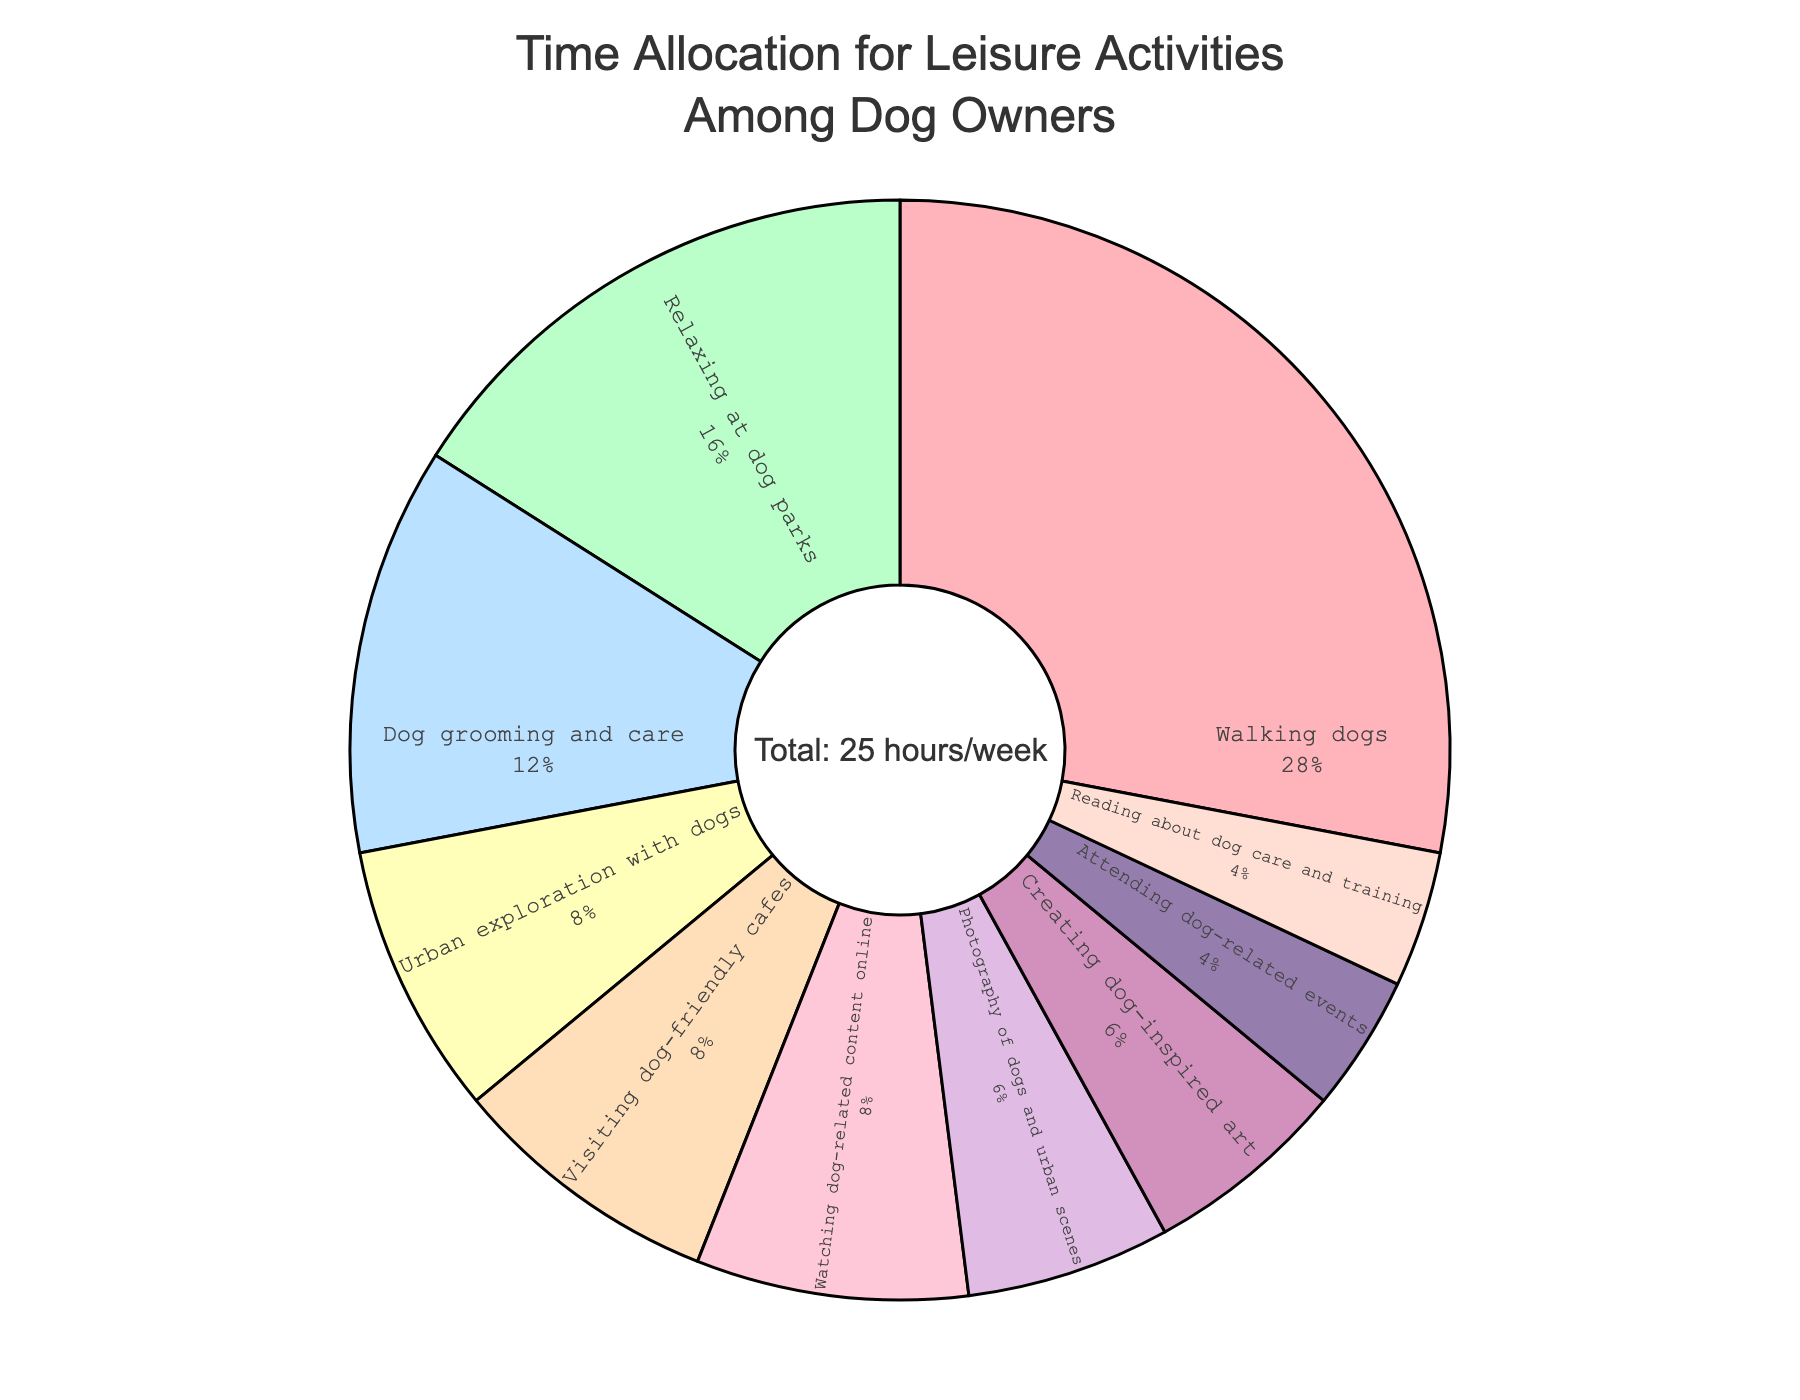How much time do dog owners spend walking their dogs compared to visiting dog-friendly cafes? Dog owners spend 7 hours walking their dogs and 2 hours visiting dog-friendly cafes. To compare, 7 hours is more than 2 hours.
Answer: 7 hours > 2 hours Which activity takes up the smallest amount of time among dog owners? The activity that takes up the smallest amount of time is attending dog-related events, which is 1 hour per week.
Answer: Attending dog-related events What percentage of time is spent on dog grooming and care? The total time per week is 25 hours. Dog grooming and care takes up 3 hours. The percentage is (3/25) * 100% = 12%.
Answer: 12% How much more time do dog owners spend on relaxing at dog parks compared to reading about dog care and training? Dog owners spend 4 hours relaxing at dog parks and 1 hour reading about dog care and training. The difference is 4 - 1 = 3 hours.
Answer: 3 hours Is the time spent on watching dog-related content online greater than or equal to the time spent on urban exploration with dogs? Dog owners spend 2 hours watching dog-related content online and 2 hours on urban exploration with dogs. Since 2 hours is equal to 2 hours, the statement is true.
Answer: Yes, it's equal What is the combined percentage of time spent on photography of dogs and creating dog-inspired art? Both activities take 1.5 hours each. The combined time is 1.5 + 1.5 = 3 hours. The percentage is (3/25) * 100% = 12%.
Answer: 12% How much time is allocated in total to activities that occur specifically outside? Activities outside include walking dogs, relaxing at dog parks, urban exploration with dogs, and visiting dog-friendly cafes, which sum to 7 + 4 + 2 + 2 = 15 hours.
Answer: 15 hours 